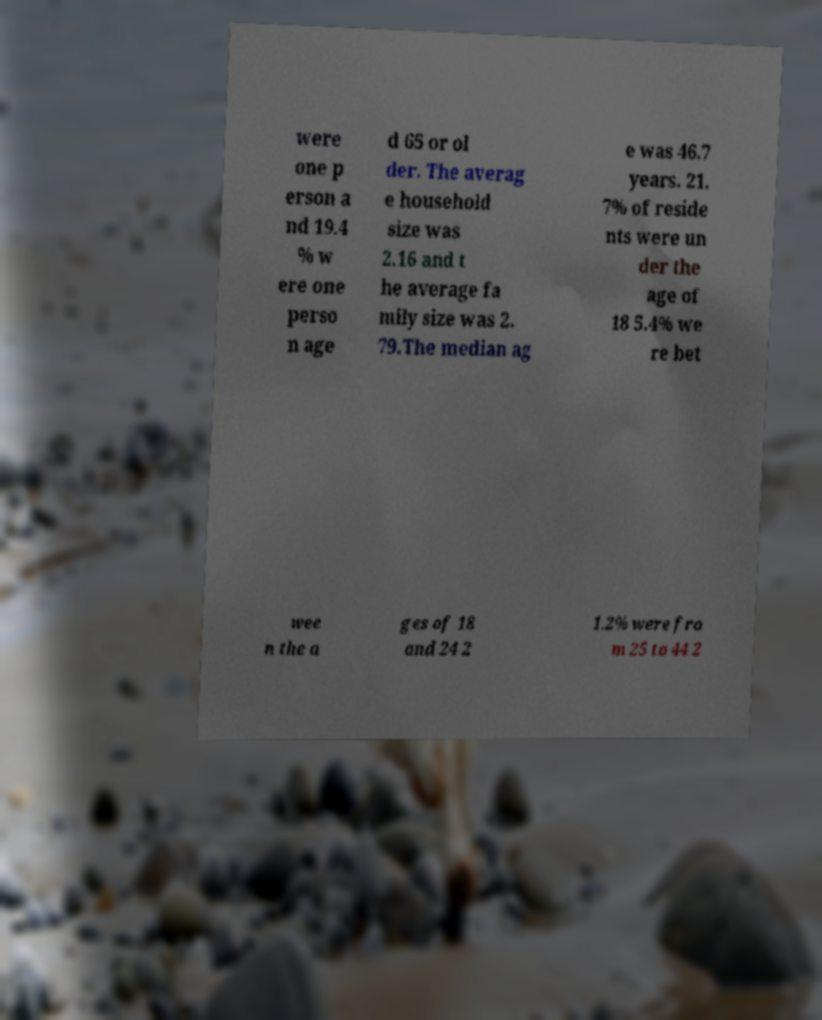Could you extract and type out the text from this image? were one p erson a nd 19.4 % w ere one perso n age d 65 or ol der. The averag e household size was 2.16 and t he average fa mily size was 2. 79.The median ag e was 46.7 years. 21. 7% of reside nts were un der the age of 18 5.4% we re bet wee n the a ges of 18 and 24 2 1.2% were fro m 25 to 44 2 